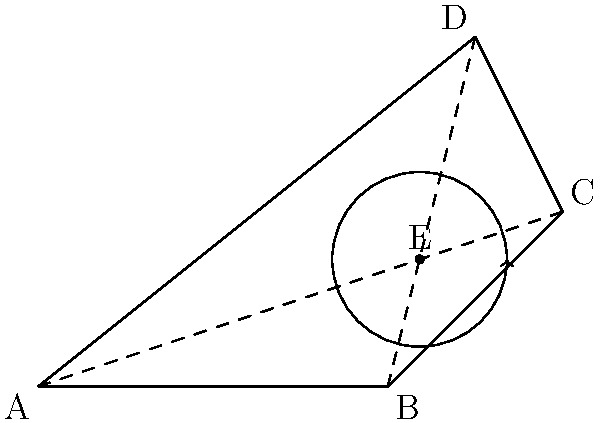In modeling a horse's leg movement during a trot, we represent the leg as a quadrilateral ABCD. The leg undergoes a rotation followed by a translation. If point E is the center of rotation, and the rotation is 45° clockwise followed by a translation of 3 units to the right, what transformation would bring point A back to its original position? To solve this problem, we need to consider the transformations applied and then determine the inverse transformations to bring point A back to its original position. Let's break it down step-by-step:

1) First transformation: 45° clockwise rotation around point E
   - Inverse: 45° counterclockwise rotation around point E

2) Second transformation: Translation 3 units to the right
   - Inverse: Translation 3 units to the left

3) To bring point A back to its original position, we need to apply these inverse transformations in reverse order:

   a) First, translate 3 units to the left
   b) Then, rotate 45° counterclockwise around point E

4) These two transformations can be composed into a single transformation:
   - A rotation of 45° counterclockwise around a point that is 3 units to the left of E

5) In transformational geometry, this is equivalent to a rotation around a different center point

Therefore, the single transformation that would bring point A back to its original position is a 45° counterclockwise rotation around a center located 3 units to the left of point E.
Answer: 45° counterclockwise rotation around a point 3 units left of E 